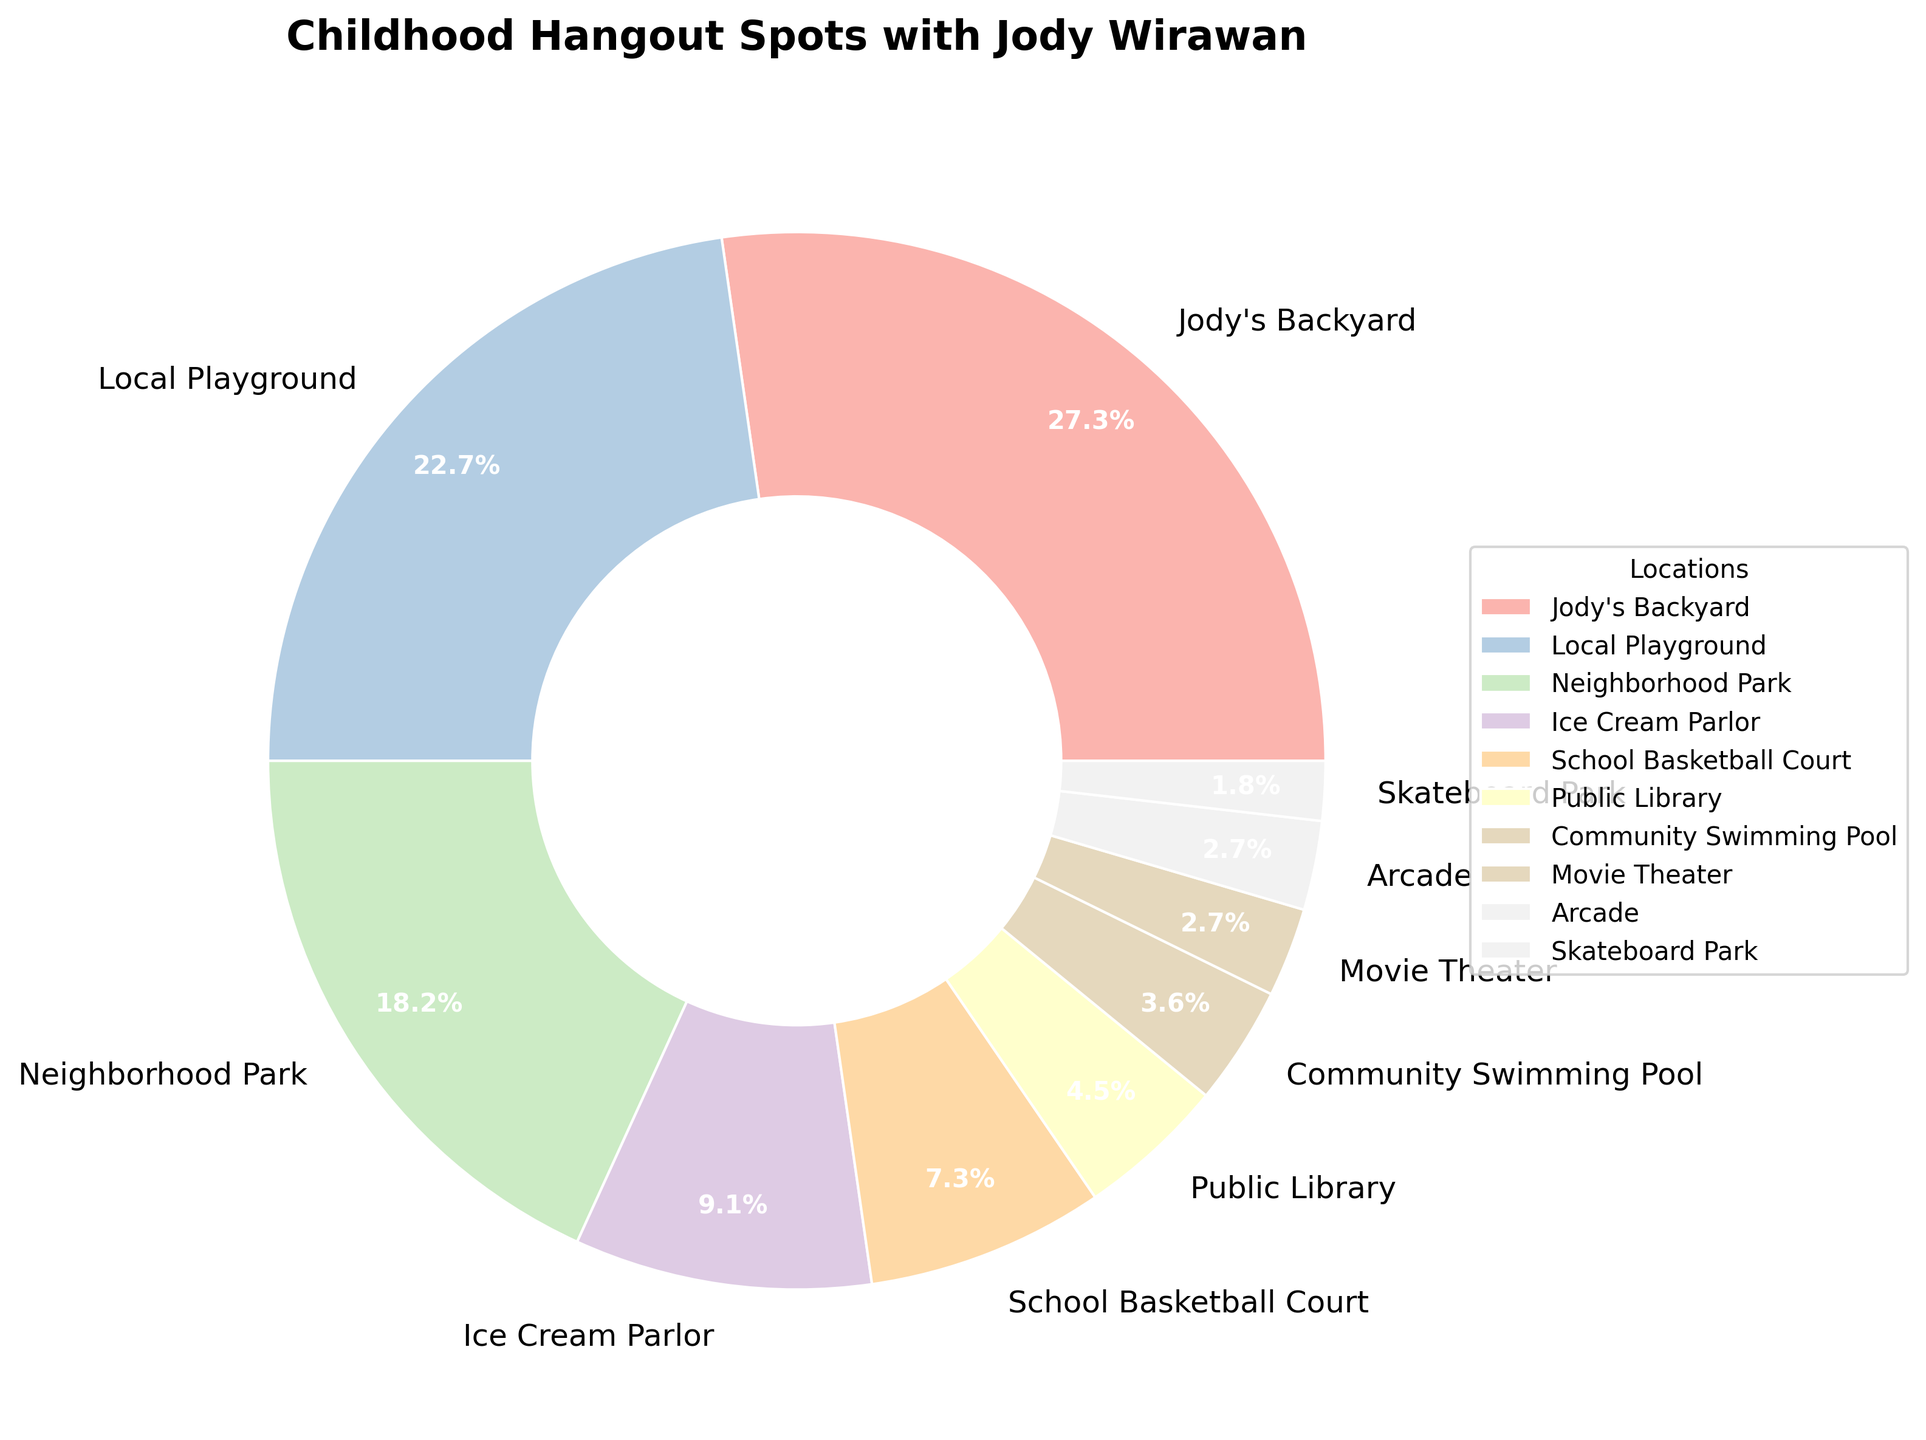Which hangout spot was frequented the most often? The pie chart clearly indicates that Jody's Backyard has the largest wedge, and the percentage shown is 30%.
Answer: Jody's Backyard Which hangout spots were frequented less than the Public Library? The pie chart shows that the Public Library’s wedge represents 5%, and anything less than 5% would be the Community Swimming Pool (4%), Movie Theater (3%), Arcade (3%), and Skateboard Park (2%).
Answer: Community Swimming Pool, Movie Theater, Arcade, Skateboard Park How many hangout spots received a frequency of 10% or higher? The pie chart shows the percentage for each location. Jody's Backyard (30%), Local Playground (25%), and Neighborhood Park (20%) are the only spots with a frequency of 10% or higher. This totals to 3 spots.
Answer: 3 What is the total percentage for hangout spots associated with sports? The locations associated with sports based on the chart are School Basketball Court (8%) and Skateboard Park (2%). Adding these together gives 8% + 2% = 10%.
Answer: 10% If you combined the frequency percentages of the Ice Cream Parlor and the School Basketball Court, would it exceed that of the Neighborhood Park? The chart shows that the Ice Cream Parlor is 10% and the School Basketball Court is 8%. Combined, they make up 18%. The Neighborhood Park is 20%, so 18% does not exceed 20%.
Answer: No Which location has the smallest wedge on the chart? The pie chart data indicates that the Skateboard Park has the smallest wedge, with a frequency of 2%.
Answer: Skateboard Park How does the frequency of visits to the Local Playground compare with the Neighborhood Park? The pie chart indicates that the Local Playground has a 25% frequency and the Neighborhood Park has a 20% frequency. 25% is greater than 20%.
Answer: The Local Playground was frequented more often than the Neighborhood Park What is the average frequency of the top three most visited locations? The top three most visited locations are Jody's Backyard (30%), Local Playground (25%), and Neighborhood Park (20%). The average frequency is calculated by (30% + 25% + 20%) / 3 = 75% / 3 = 25%.
Answer: 25% What percentage of the hangout spots have a frequency equal to or less than the Ice Cream Parlor? Ice Cream Parlor has a frequency of 10%. Other spots with frequency equal to or less than 10% are School Basketball Court (8%), Public Library (5%), Community Swimming Pool (4%), Movie Theater (3%), Arcade (3%), and Skateboard Park (2%). Summing these, 10% + 8% + 5% + 4% + 3% + 3% + 2% = 35%.
Answer: 35% What childhood hangout spot did you and Jody Wirawan visit the fewest times? The pie chart indicates that the Skateboard Park has the smallest wedge with 2%, representing the fewest visits.
Answer: Skateboard Park What is the difference in hangout frequency between the Ice Cream Parlor and the School Basketball Court? From the pie chart, the Ice Cream Parlor has a frequency of 10%, and the School Basketball Court has a frequency of 8%. The difference between them is 10% - 8% = 2%.
Answer: 2% 